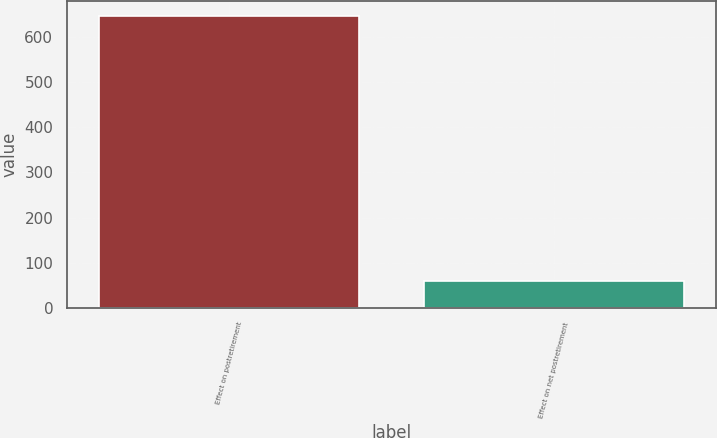Convert chart to OTSL. <chart><loc_0><loc_0><loc_500><loc_500><bar_chart><fcel>Effect on postretirement<fcel>Effect on net postretirement<nl><fcel>647<fcel>59<nl></chart> 